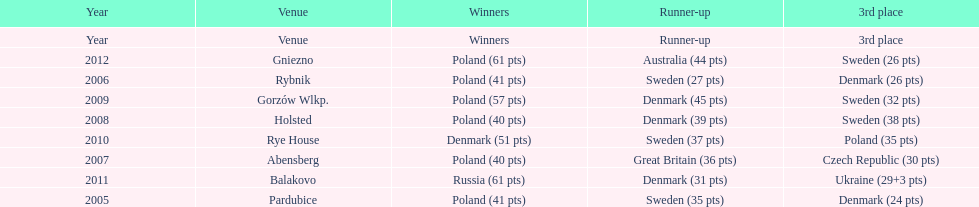Which team has the most third place wins in the speedway junior world championship between 2005 and 2012? Sweden. 